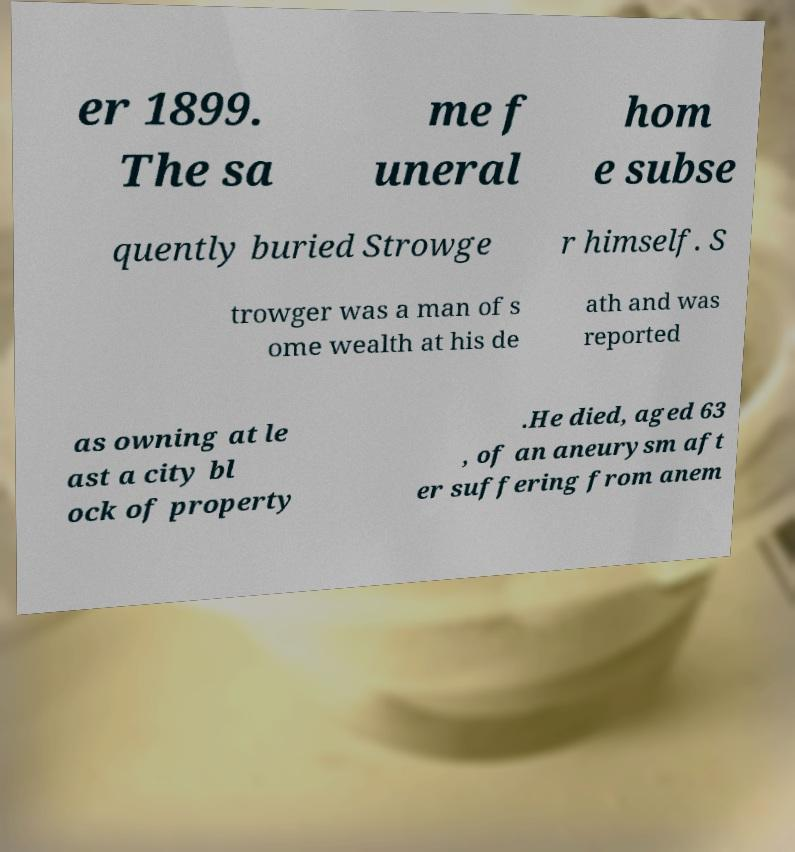There's text embedded in this image that I need extracted. Can you transcribe it verbatim? er 1899. The sa me f uneral hom e subse quently buried Strowge r himself. S trowger was a man of s ome wealth at his de ath and was reported as owning at le ast a city bl ock of property .He died, aged 63 , of an aneurysm aft er suffering from anem 